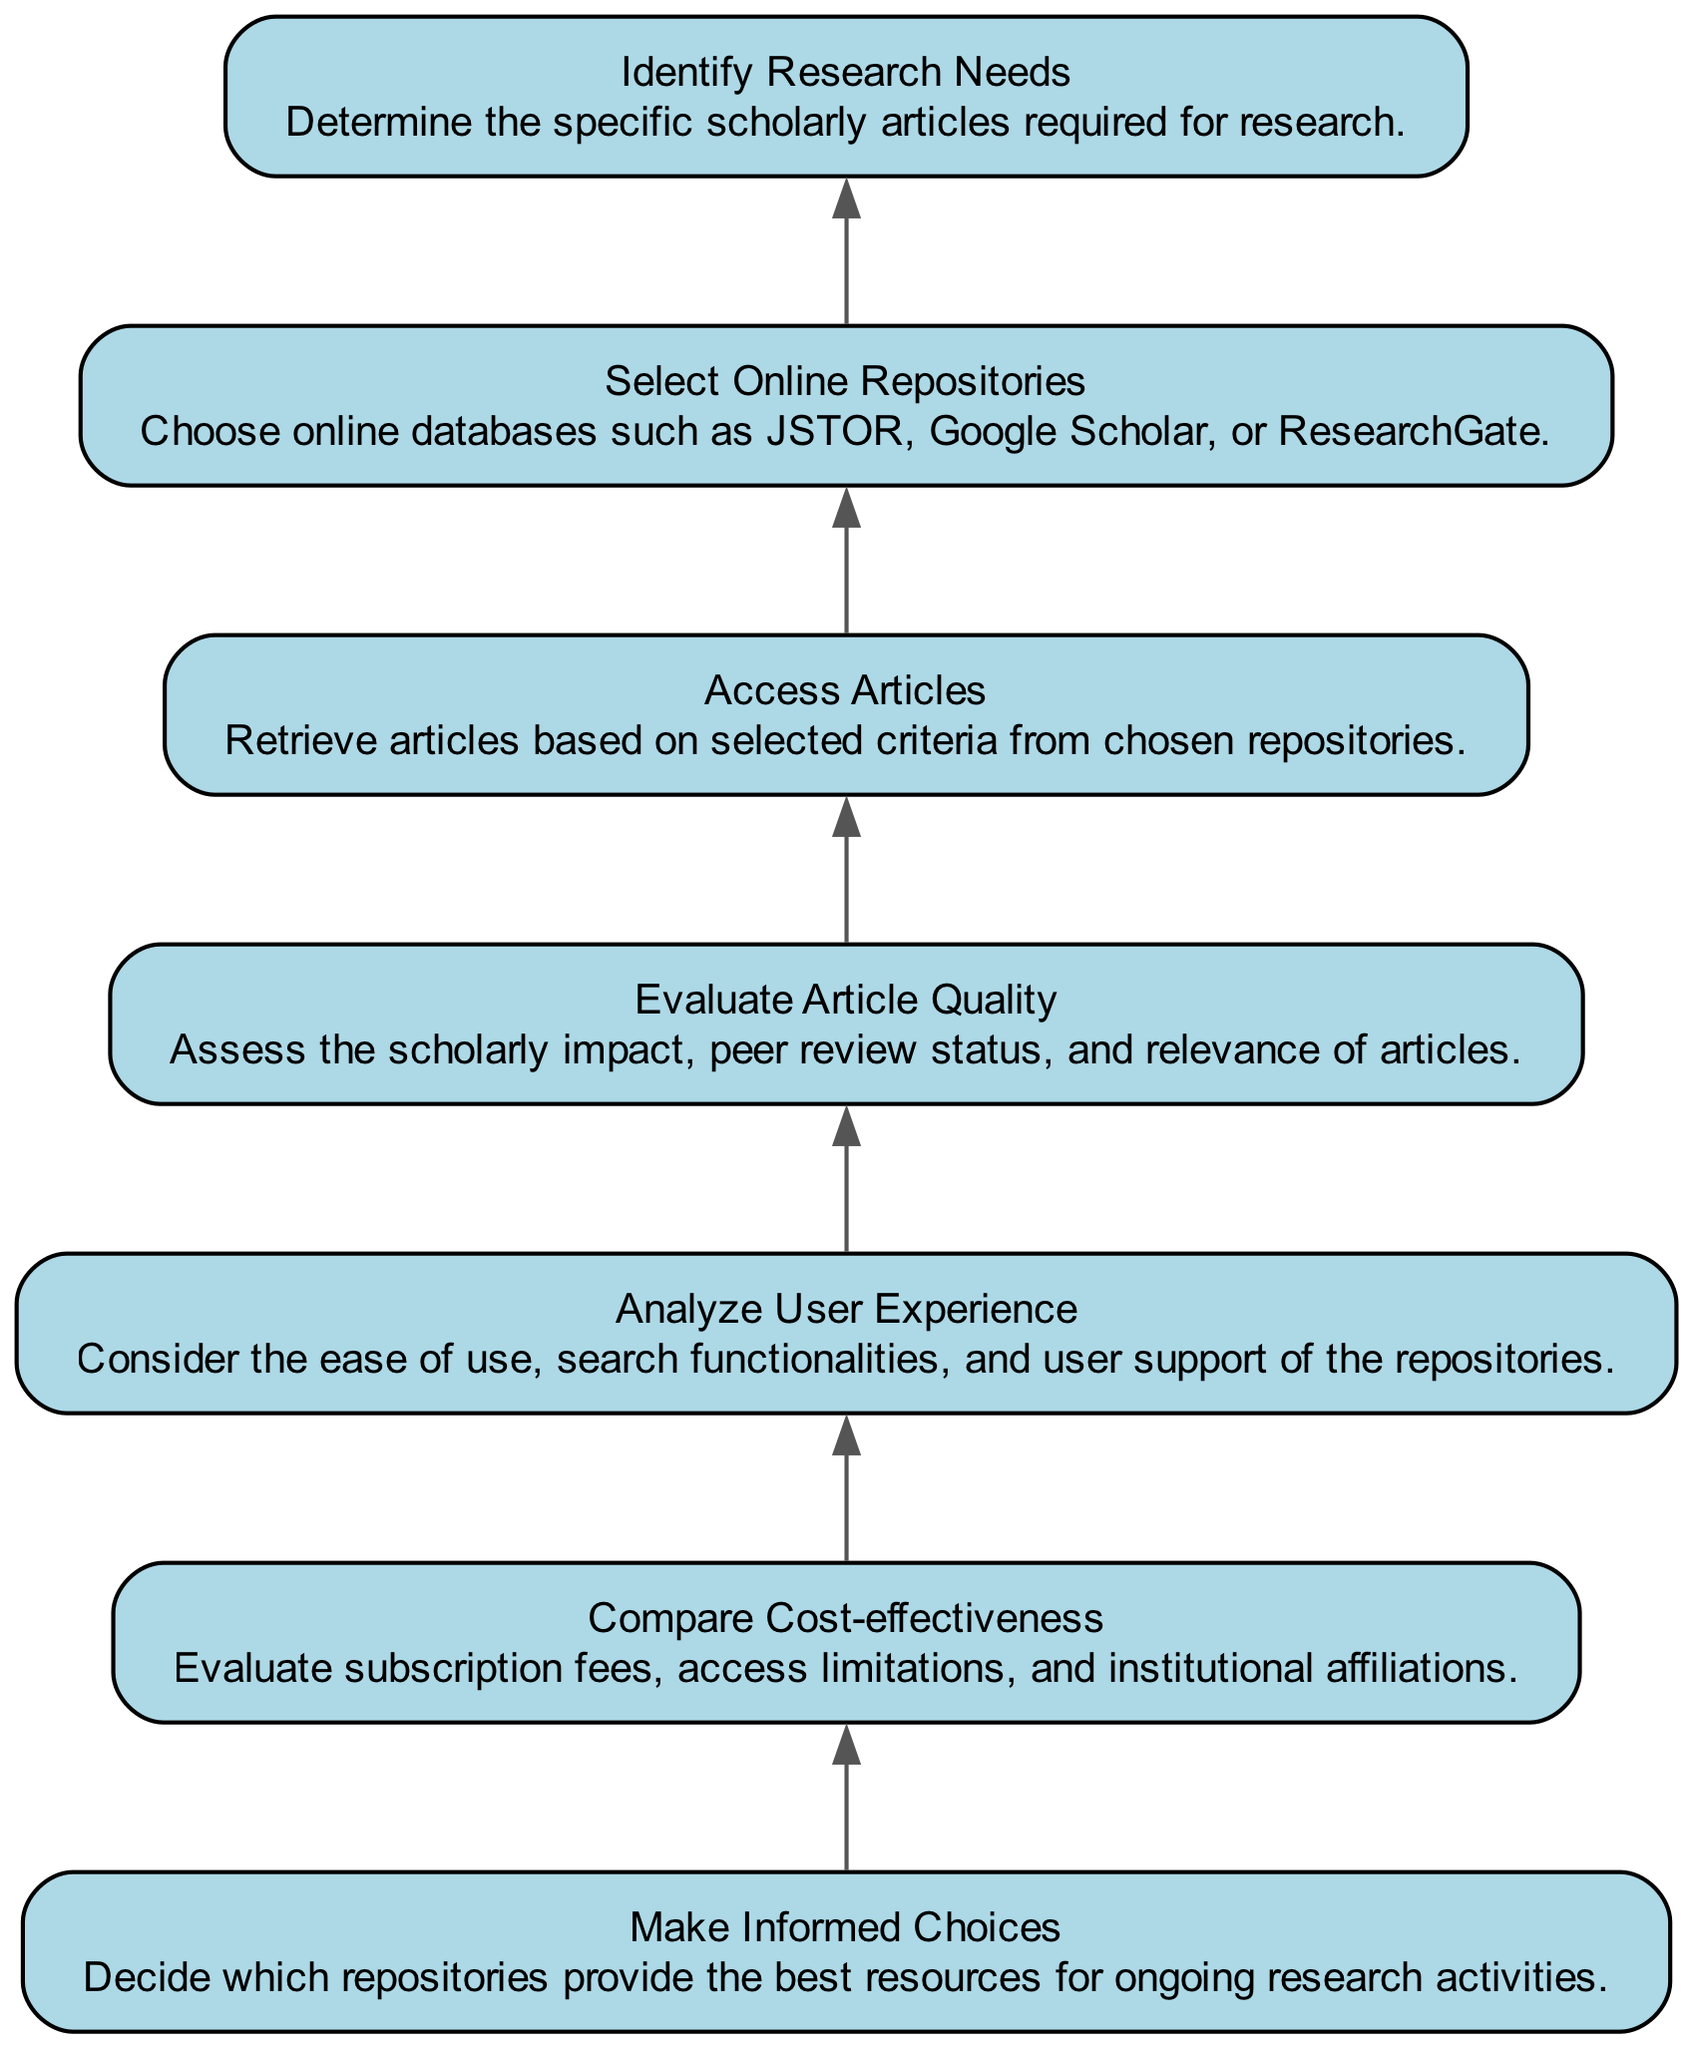What's the first step in the flowchart? The flowchart begins with "Identify Research Needs," which is the initial node representing the starting action of the evaluation process.
Answer: Identify Research Needs How many total nodes are present in the diagram? The diagram contains a total of seven nodes, each representing a distinct step in the evaluation process.
Answer: 7 What is the last step before making informed choices? The final step before "Make Informed Choices" is "Compare Cost-effectiveness," which evaluates financial aspects before deciding.
Answer: Compare Cost-effectiveness Which node focuses on the usability of the repositories? "Analyze User Experience" directly addresses the ease of use and functionality of the online repositories.
Answer: Analyze User Experience What are the two aspects examined in "Evaluate Article Quality"? The process in "Evaluate Article Quality" assesses scholarly impact and peer review status to determine the quality of the articles.
Answer: Scholarly impact, peer review status What comes after selecting online repositories? After "Select Online Repositories," the next step in the flow is "Access Articles," indicating that articles are retrieved from chosen databases.
Answer: Access Articles Which step is directly linked to article retrieval? "Access Articles" is the step that directly involves retrieving articles from the selected online repositories.
Answer: Access Articles What are the two major focuses of "Compare Cost-effectiveness"? The major focuses are evaluating subscription fees and access limitations, which impact the overall cost-effectiveness of the repositories.
Answer: Subscription fees, access limitations 